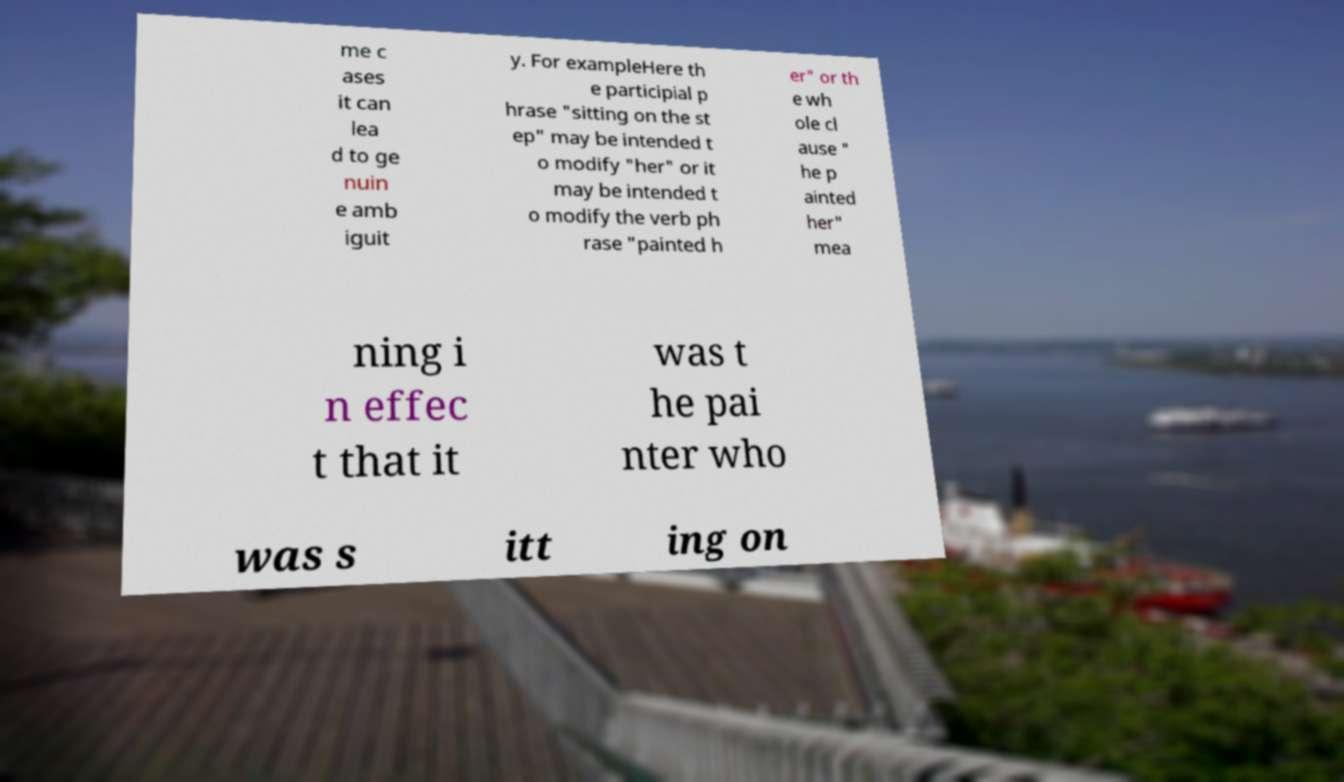For documentation purposes, I need the text within this image transcribed. Could you provide that? me c ases it can lea d to ge nuin e amb iguit y. For exampleHere th e participial p hrase "sitting on the st ep" may be intended t o modify "her" or it may be intended t o modify the verb ph rase "painted h er" or th e wh ole cl ause " he p ainted her" mea ning i n effec t that it was t he pai nter who was s itt ing on 